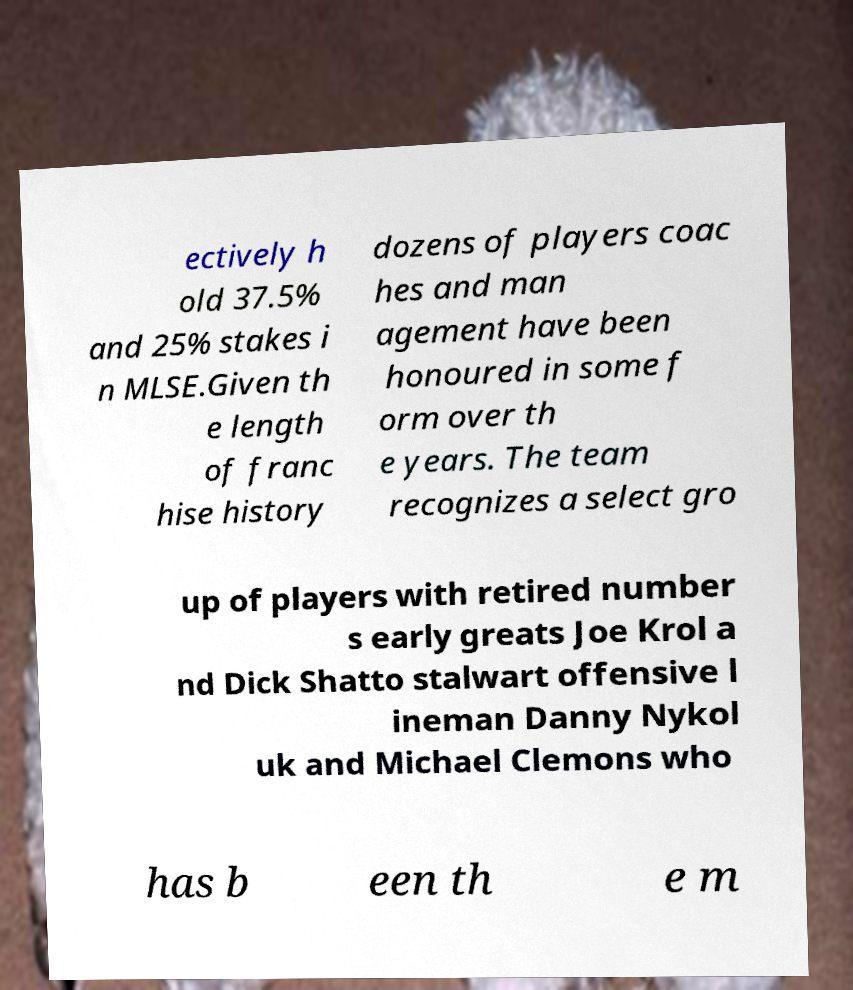There's text embedded in this image that I need extracted. Can you transcribe it verbatim? ectively h old 37.5% and 25% stakes i n MLSE.Given th e length of franc hise history dozens of players coac hes and man agement have been honoured in some f orm over th e years. The team recognizes a select gro up of players with retired number s early greats Joe Krol a nd Dick Shatto stalwart offensive l ineman Danny Nykol uk and Michael Clemons who has b een th e m 